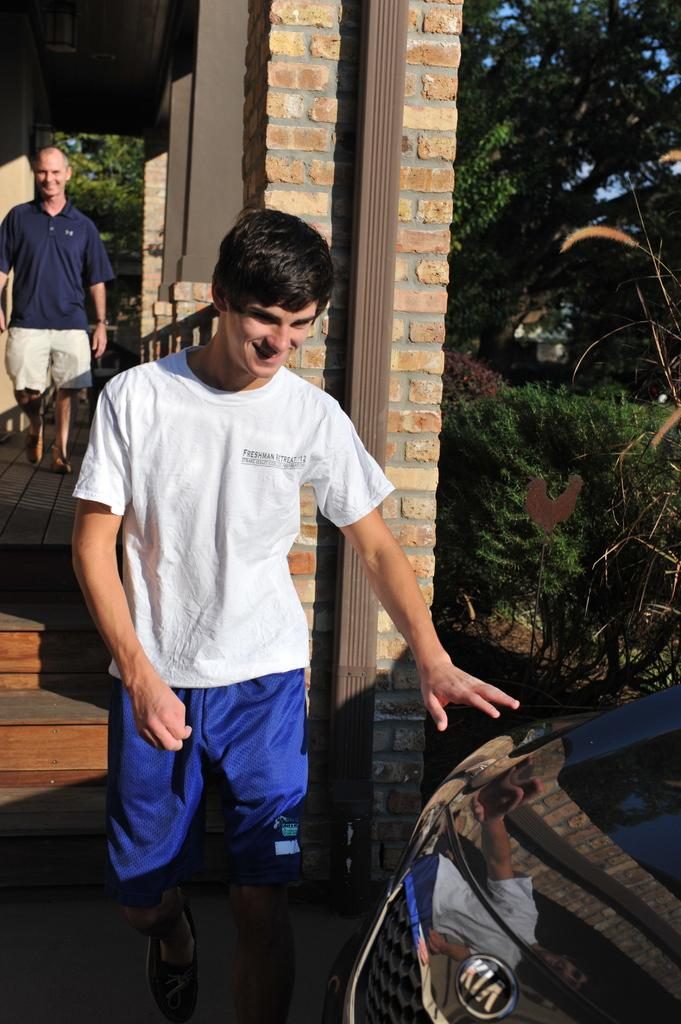How many people are present in the image? There are two people standing in the image. What can be seen in the background of the image? There are concrete poles and trees on the right side of the image. Is there any vehicle visible in the image? Yes, there is a car in the right bottom corner of the image. What type of carpenter tools can be seen in the image? There are no carpenter tools present in the image. Is there a boat visible in the image? No, there is no boat visible in the image. 